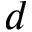<formula> <loc_0><loc_0><loc_500><loc_500>d</formula> 